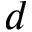<formula> <loc_0><loc_0><loc_500><loc_500>d</formula> 